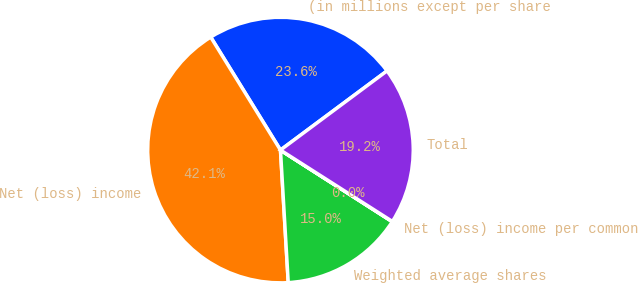<chart> <loc_0><loc_0><loc_500><loc_500><pie_chart><fcel>(in millions except per share<fcel>Net (loss) income<fcel>Weighted average shares<fcel>Net (loss) income per common<fcel>Total<nl><fcel>23.63%<fcel>42.13%<fcel>15.0%<fcel>0.03%<fcel>19.21%<nl></chart> 